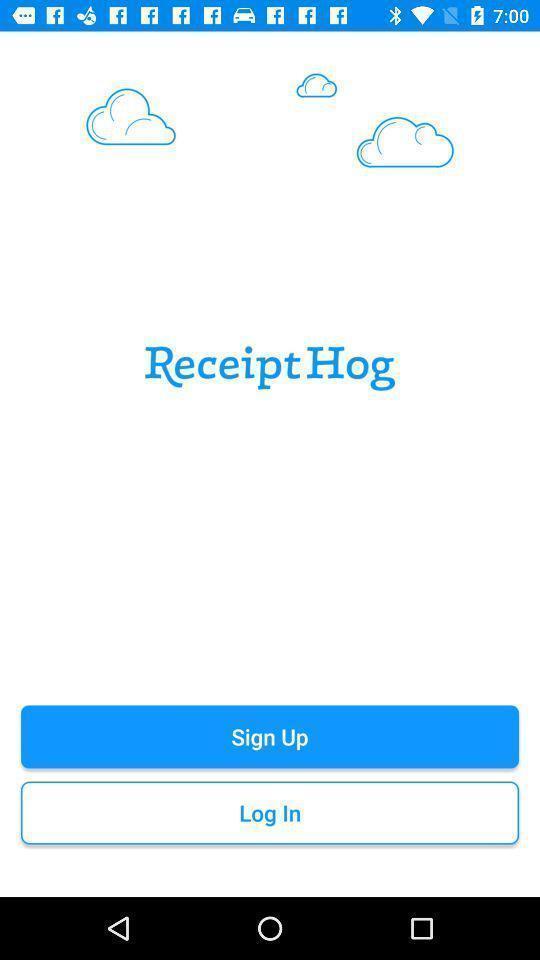Summarize the information in this screenshot. Sign up page for the financial app. 